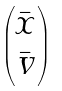<formula> <loc_0><loc_0><loc_500><loc_500>\begin{pmatrix} \bar { x } \\ \bar { v } \end{pmatrix}</formula> 